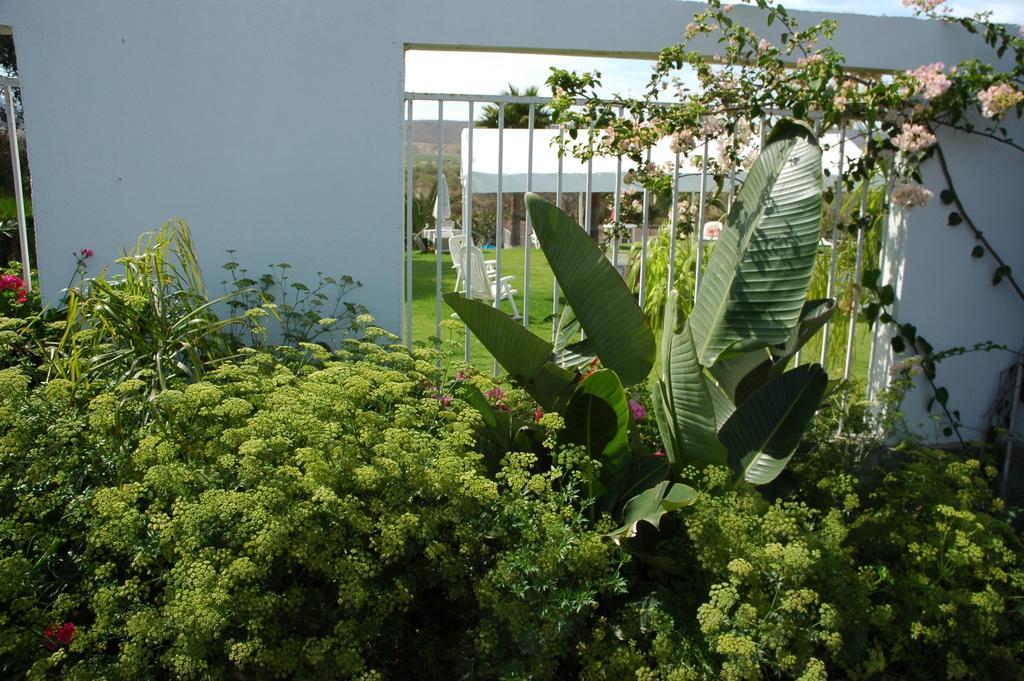Describe this image in one or two sentences. In this image we can see a tent and some chairs placed on the grass field. In the foreground of the image we can see some flowers on the plants, fence and a wall. In the background, we can see some trees and the sky. 